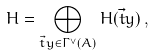<formula> <loc_0><loc_0><loc_500><loc_500>H = \bigoplus _ { \vec { t } y \in \Gamma ^ { \vee } ( A ) } H ( { \vec { t } y } ) \, ,</formula> 